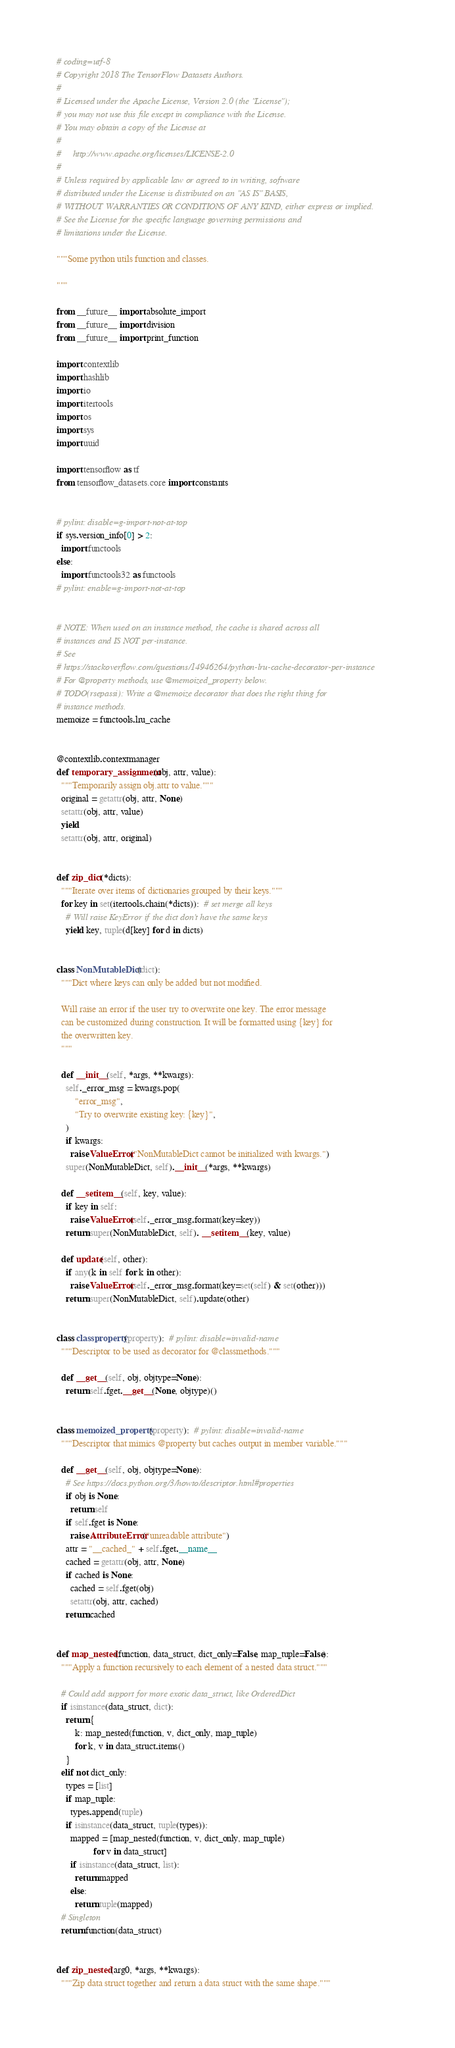<code> <loc_0><loc_0><loc_500><loc_500><_Python_># coding=utf-8
# Copyright 2018 The TensorFlow Datasets Authors.
#
# Licensed under the Apache License, Version 2.0 (the "License");
# you may not use this file except in compliance with the License.
# You may obtain a copy of the License at
#
#     http://www.apache.org/licenses/LICENSE-2.0
#
# Unless required by applicable law or agreed to in writing, software
# distributed under the License is distributed on an "AS IS" BASIS,
# WITHOUT WARRANTIES OR CONDITIONS OF ANY KIND, either express or implied.
# See the License for the specific language governing permissions and
# limitations under the License.

"""Some python utils function and classes.

"""

from __future__ import absolute_import
from __future__ import division
from __future__ import print_function

import contextlib
import hashlib
import io
import itertools
import os
import sys
import uuid

import tensorflow as tf
from tensorflow_datasets.core import constants


# pylint: disable=g-import-not-at-top
if sys.version_info[0] > 2:
  import functools
else:
  import functools32 as functools
# pylint: enable=g-import-not-at-top


# NOTE: When used on an instance method, the cache is shared across all
# instances and IS NOT per-instance.
# See
# https://stackoverflow.com/questions/14946264/python-lru-cache-decorator-per-instance
# For @property methods, use @memoized_property below.
# TODO(rsepassi): Write a @memoize decorator that does the right thing for
# instance methods.
memoize = functools.lru_cache


@contextlib.contextmanager
def temporary_assignment(obj, attr, value):
  """Temporarily assign obj.attr to value."""
  original = getattr(obj, attr, None)
  setattr(obj, attr, value)
  yield
  setattr(obj, attr, original)


def zip_dict(*dicts):
  """Iterate over items of dictionaries grouped by their keys."""
  for key in set(itertools.chain(*dicts)):  # set merge all keys
    # Will raise KeyError if the dict don't have the same keys
    yield key, tuple(d[key] for d in dicts)


class NonMutableDict(dict):
  """Dict where keys can only be added but not modified.

  Will raise an error if the user try to overwrite one key. The error message
  can be customized during construction. It will be formatted using {key} for
  the overwritten key.
  """

  def __init__(self, *args, **kwargs):
    self._error_msg = kwargs.pop(
        "error_msg",
        "Try to overwrite existing key: {key}",
    )
    if kwargs:
      raise ValueError("NonMutableDict cannot be initialized with kwargs.")
    super(NonMutableDict, self).__init__(*args, **kwargs)

  def __setitem__(self, key, value):
    if key in self:
      raise ValueError(self._error_msg.format(key=key))
    return super(NonMutableDict, self). __setitem__(key, value)

  def update(self, other):
    if any(k in self for k in other):
      raise ValueError(self._error_msg.format(key=set(self) & set(other)))
    return super(NonMutableDict, self).update(other)


class classproperty(property):  # pylint: disable=invalid-name
  """Descriptor to be used as decorator for @classmethods."""

  def __get__(self, obj, objtype=None):
    return self.fget.__get__(None, objtype)()


class memoized_property(property):  # pylint: disable=invalid-name
  """Descriptor that mimics @property but caches output in member variable."""

  def __get__(self, obj, objtype=None):
    # See https://docs.python.org/3/howto/descriptor.html#properties
    if obj is None:
      return self
    if self.fget is None:
      raise AttributeError("unreadable attribute")
    attr = "__cached_" + self.fget.__name__
    cached = getattr(obj, attr, None)
    if cached is None:
      cached = self.fget(obj)
      setattr(obj, attr, cached)
    return cached


def map_nested(function, data_struct, dict_only=False, map_tuple=False):
  """Apply a function recursively to each element of a nested data struct."""

  # Could add support for more exotic data_struct, like OrderedDict
  if isinstance(data_struct, dict):
    return {
        k: map_nested(function, v, dict_only, map_tuple)
        for k, v in data_struct.items()
    }
  elif not dict_only:
    types = [list]
    if map_tuple:
      types.append(tuple)
    if isinstance(data_struct, tuple(types)):
      mapped = [map_nested(function, v, dict_only, map_tuple)
                for v in data_struct]
      if isinstance(data_struct, list):
        return mapped
      else:
        return tuple(mapped)
  # Singleton
  return function(data_struct)


def zip_nested(arg0, *args, **kwargs):
  """Zip data struct together and return a data struct with the same shape."""</code> 